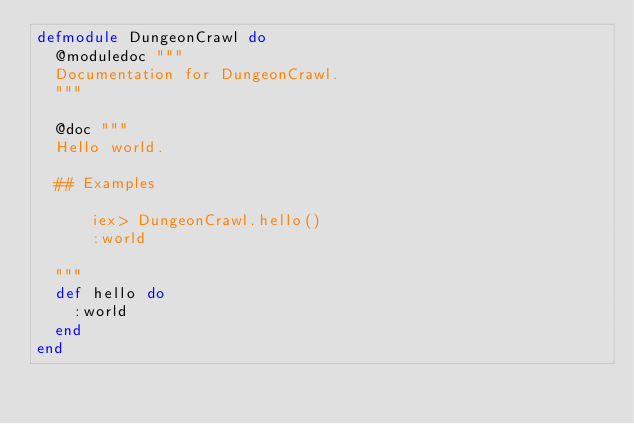Convert code to text. <code><loc_0><loc_0><loc_500><loc_500><_Elixir_>defmodule DungeonCrawl do
  @moduledoc """
  Documentation for DungeonCrawl.
  """

  @doc """
  Hello world.

  ## Examples

      iex> DungeonCrawl.hello()
      :world

  """
  def hello do
    :world
  end
end
</code> 